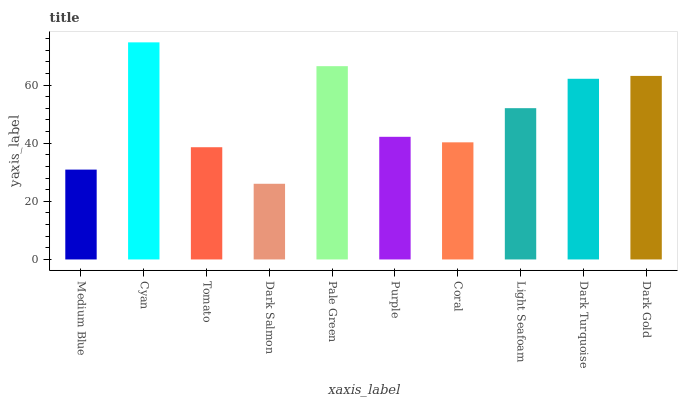Is Dark Salmon the minimum?
Answer yes or no. Yes. Is Cyan the maximum?
Answer yes or no. Yes. Is Tomato the minimum?
Answer yes or no. No. Is Tomato the maximum?
Answer yes or no. No. Is Cyan greater than Tomato?
Answer yes or no. Yes. Is Tomato less than Cyan?
Answer yes or no. Yes. Is Tomato greater than Cyan?
Answer yes or no. No. Is Cyan less than Tomato?
Answer yes or no. No. Is Light Seafoam the high median?
Answer yes or no. Yes. Is Purple the low median?
Answer yes or no. Yes. Is Dark Turquoise the high median?
Answer yes or no. No. Is Cyan the low median?
Answer yes or no. No. 